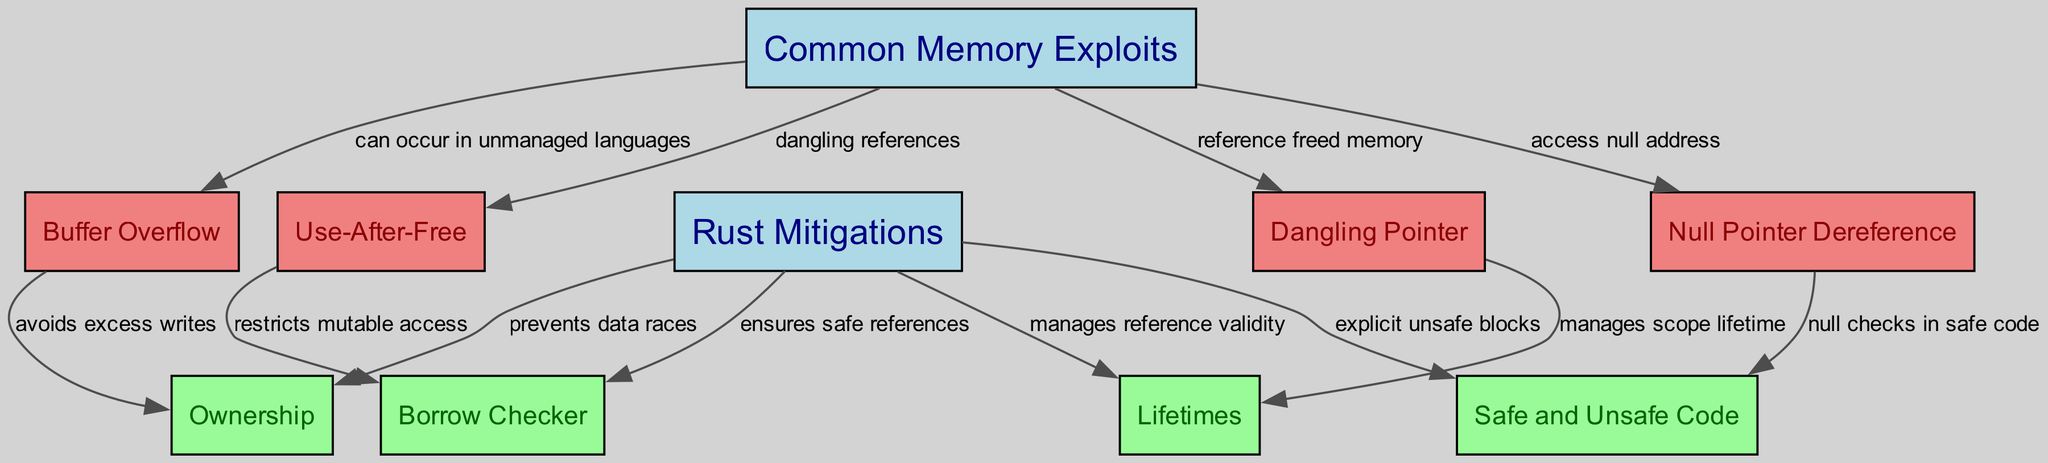What are the common memory exploits listed in the diagram? The diagram specifically lists four common memory exploits: Buffer Overflow, Use-After-Free, Null Pointer Dereference, and Dangling Pointer. These nodes are connected to "Common Memory Exploits," making them easily identifiable.
Answer: Buffer Overflow, Use-After-Free, Null Pointer Dereference, Dangling Pointer How many mitigation strategies are there in the diagram? There are four distinct mitigation strategies described in the diagram: Ownership, Borrow Checker, Lifetimes, and Safe and Unsafe Code. These are connected to the "Rust Mitigations" node.
Answer: Four What relationship exists between Buffer Overflow and Ownership? The diagram illustrates that Ownership can help avoid excess writes, which is a common cause of Buffer Overflow in unmanaged languages. This direct relationship indicates how Rust's Ownership feature specifically addresses this exploit.
Answer: Avoids excess writes Which memory exploit is associated with dangling references? Use-After-Free is the memory exploit associated with dangling references, as indicated by the edge that connects the two nodes in the diagram. This reflects the nature of the vulnerability where references persist even after the memory they point to is freed.
Answer: Use-After-Free How does Lifetimes mitigate Dangling Pointer? Lifetimes manage the scope of references and hence their validity, preventing Dangling Pointers that reference freed memory. The diagram explicitly connects Lifetimes to Dangling Pointer, indicating this mitigation method’s role.
Answer: Manages scope lifetime What do safe checks in null pointer dereference provide? Safe and Unsafe Code node is connected to Null Pointer Dereference, indicating that null checks in safe code provide a means to prevent null pointer dereference vulnerabilities by ensuring that access to such addresses is managed.
Answer: Null checks in safe code Which Rust mitigation strategy ensures safe references? The Borrow Checker is the specific mitigation strategy that ensures safe references, as evidenced by the connection from "Rust Mitigations" to the "Borrow Checker" node in the diagram.
Answer: Borrow Checker Which type of languages can experience Buffer Overflow according to the diagram? The diagram states that Buffer Overflow can occur in unmanaged languages, indicating that these languages do not have built-in protections against this type of exploit.
Answer: Unmanaged languages 